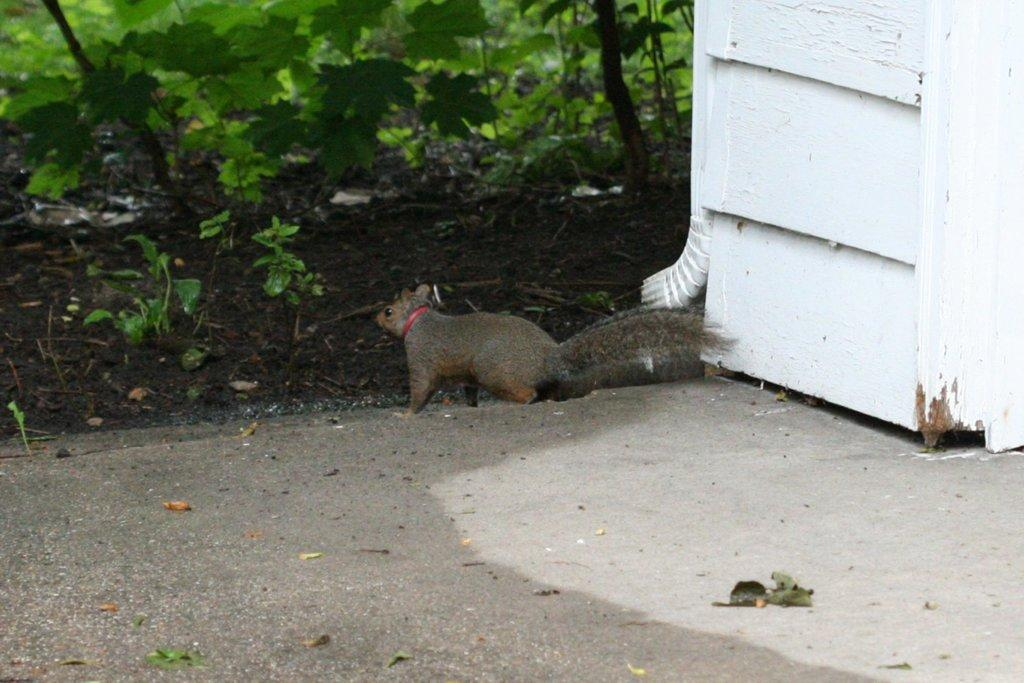What type of animal is in the image? There is a squirrel in the image. What color is the squirrel? The squirrel is brown in color. What else can be seen in the image besides the squirrel? There are plants in the image. What color are the plants? The plants are green in color. Can you describe the white object in the image? There is a white object in the image, but its specific nature is not mentioned in the provided facts. What type of account does the squirrel have in the image? There is no mention of an account in the image, as it features a squirrel and plants. 